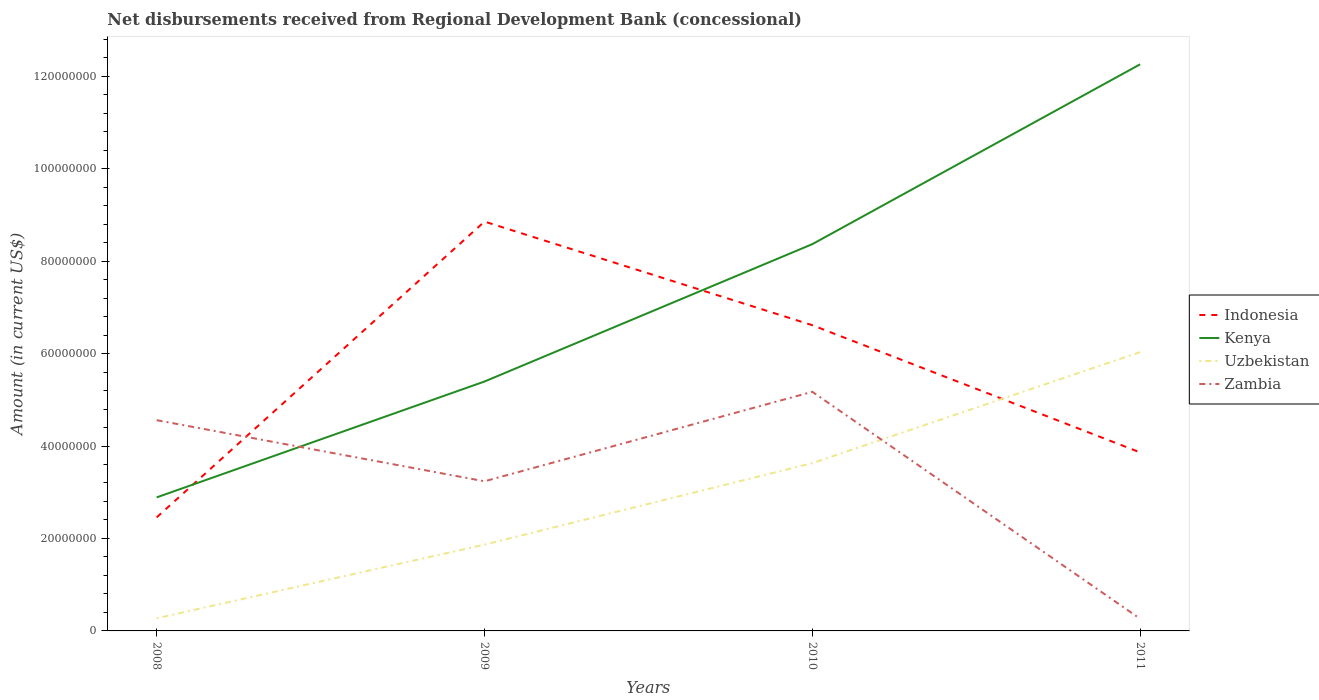Is the number of lines equal to the number of legend labels?
Ensure brevity in your answer.  Yes. Across all years, what is the maximum amount of disbursements received from Regional Development Bank in Kenya?
Make the answer very short. 2.89e+07. What is the total amount of disbursements received from Regional Development Bank in Indonesia in the graph?
Provide a short and direct response. -4.16e+07. What is the difference between the highest and the second highest amount of disbursements received from Regional Development Bank in Kenya?
Offer a terse response. 9.37e+07. How many years are there in the graph?
Your response must be concise. 4. What is the difference between two consecutive major ticks on the Y-axis?
Ensure brevity in your answer.  2.00e+07. Does the graph contain grids?
Your response must be concise. No. Where does the legend appear in the graph?
Make the answer very short. Center right. How many legend labels are there?
Make the answer very short. 4. What is the title of the graph?
Offer a very short reply. Net disbursements received from Regional Development Bank (concessional). Does "East Asia (all income levels)" appear as one of the legend labels in the graph?
Your answer should be compact. No. What is the label or title of the X-axis?
Provide a short and direct response. Years. What is the label or title of the Y-axis?
Offer a very short reply. Amount (in current US$). What is the Amount (in current US$) in Indonesia in 2008?
Make the answer very short. 2.46e+07. What is the Amount (in current US$) of Kenya in 2008?
Ensure brevity in your answer.  2.89e+07. What is the Amount (in current US$) of Uzbekistan in 2008?
Provide a short and direct response. 2.73e+06. What is the Amount (in current US$) of Zambia in 2008?
Make the answer very short. 4.56e+07. What is the Amount (in current US$) of Indonesia in 2009?
Offer a very short reply. 8.86e+07. What is the Amount (in current US$) in Kenya in 2009?
Make the answer very short. 5.40e+07. What is the Amount (in current US$) in Uzbekistan in 2009?
Offer a terse response. 1.87e+07. What is the Amount (in current US$) of Zambia in 2009?
Give a very brief answer. 3.24e+07. What is the Amount (in current US$) in Indonesia in 2010?
Offer a very short reply. 6.61e+07. What is the Amount (in current US$) of Kenya in 2010?
Provide a succinct answer. 8.37e+07. What is the Amount (in current US$) in Uzbekistan in 2010?
Keep it short and to the point. 3.63e+07. What is the Amount (in current US$) of Zambia in 2010?
Your response must be concise. 5.17e+07. What is the Amount (in current US$) of Indonesia in 2011?
Make the answer very short. 3.86e+07. What is the Amount (in current US$) in Kenya in 2011?
Ensure brevity in your answer.  1.23e+08. What is the Amount (in current US$) in Uzbekistan in 2011?
Your answer should be compact. 6.03e+07. What is the Amount (in current US$) of Zambia in 2011?
Provide a short and direct response. 2.63e+06. Across all years, what is the maximum Amount (in current US$) of Indonesia?
Your answer should be very brief. 8.86e+07. Across all years, what is the maximum Amount (in current US$) of Kenya?
Your answer should be very brief. 1.23e+08. Across all years, what is the maximum Amount (in current US$) of Uzbekistan?
Your answer should be compact. 6.03e+07. Across all years, what is the maximum Amount (in current US$) in Zambia?
Make the answer very short. 5.17e+07. Across all years, what is the minimum Amount (in current US$) in Indonesia?
Provide a short and direct response. 2.46e+07. Across all years, what is the minimum Amount (in current US$) of Kenya?
Provide a succinct answer. 2.89e+07. Across all years, what is the minimum Amount (in current US$) in Uzbekistan?
Your answer should be compact. 2.73e+06. Across all years, what is the minimum Amount (in current US$) of Zambia?
Provide a succinct answer. 2.63e+06. What is the total Amount (in current US$) of Indonesia in the graph?
Keep it short and to the point. 2.18e+08. What is the total Amount (in current US$) in Kenya in the graph?
Your answer should be very brief. 2.89e+08. What is the total Amount (in current US$) of Uzbekistan in the graph?
Make the answer very short. 1.18e+08. What is the total Amount (in current US$) in Zambia in the graph?
Offer a terse response. 1.32e+08. What is the difference between the Amount (in current US$) of Indonesia in 2008 and that in 2009?
Provide a succinct answer. -6.40e+07. What is the difference between the Amount (in current US$) in Kenya in 2008 and that in 2009?
Ensure brevity in your answer.  -2.51e+07. What is the difference between the Amount (in current US$) of Uzbekistan in 2008 and that in 2009?
Provide a short and direct response. -1.59e+07. What is the difference between the Amount (in current US$) of Zambia in 2008 and that in 2009?
Keep it short and to the point. 1.32e+07. What is the difference between the Amount (in current US$) in Indonesia in 2008 and that in 2010?
Your answer should be very brief. -4.16e+07. What is the difference between the Amount (in current US$) of Kenya in 2008 and that in 2010?
Your answer should be very brief. -5.48e+07. What is the difference between the Amount (in current US$) of Uzbekistan in 2008 and that in 2010?
Your response must be concise. -3.36e+07. What is the difference between the Amount (in current US$) of Zambia in 2008 and that in 2010?
Offer a very short reply. -6.14e+06. What is the difference between the Amount (in current US$) of Indonesia in 2008 and that in 2011?
Make the answer very short. -1.40e+07. What is the difference between the Amount (in current US$) of Kenya in 2008 and that in 2011?
Provide a succinct answer. -9.37e+07. What is the difference between the Amount (in current US$) in Uzbekistan in 2008 and that in 2011?
Your response must be concise. -5.76e+07. What is the difference between the Amount (in current US$) of Zambia in 2008 and that in 2011?
Provide a short and direct response. 4.30e+07. What is the difference between the Amount (in current US$) in Indonesia in 2009 and that in 2010?
Provide a short and direct response. 2.24e+07. What is the difference between the Amount (in current US$) of Kenya in 2009 and that in 2010?
Your response must be concise. -2.97e+07. What is the difference between the Amount (in current US$) in Uzbekistan in 2009 and that in 2010?
Provide a short and direct response. -1.76e+07. What is the difference between the Amount (in current US$) in Zambia in 2009 and that in 2010?
Give a very brief answer. -1.94e+07. What is the difference between the Amount (in current US$) of Indonesia in 2009 and that in 2011?
Your answer should be compact. 4.99e+07. What is the difference between the Amount (in current US$) of Kenya in 2009 and that in 2011?
Give a very brief answer. -6.86e+07. What is the difference between the Amount (in current US$) in Uzbekistan in 2009 and that in 2011?
Your answer should be compact. -4.16e+07. What is the difference between the Amount (in current US$) of Zambia in 2009 and that in 2011?
Offer a very short reply. 2.97e+07. What is the difference between the Amount (in current US$) of Indonesia in 2010 and that in 2011?
Offer a very short reply. 2.75e+07. What is the difference between the Amount (in current US$) of Kenya in 2010 and that in 2011?
Provide a succinct answer. -3.89e+07. What is the difference between the Amount (in current US$) of Uzbekistan in 2010 and that in 2011?
Keep it short and to the point. -2.40e+07. What is the difference between the Amount (in current US$) in Zambia in 2010 and that in 2011?
Offer a very short reply. 4.91e+07. What is the difference between the Amount (in current US$) in Indonesia in 2008 and the Amount (in current US$) in Kenya in 2009?
Make the answer very short. -2.94e+07. What is the difference between the Amount (in current US$) in Indonesia in 2008 and the Amount (in current US$) in Uzbekistan in 2009?
Provide a short and direct response. 5.90e+06. What is the difference between the Amount (in current US$) of Indonesia in 2008 and the Amount (in current US$) of Zambia in 2009?
Provide a short and direct response. -7.80e+06. What is the difference between the Amount (in current US$) in Kenya in 2008 and the Amount (in current US$) in Uzbekistan in 2009?
Offer a very short reply. 1.02e+07. What is the difference between the Amount (in current US$) of Kenya in 2008 and the Amount (in current US$) of Zambia in 2009?
Provide a short and direct response. -3.48e+06. What is the difference between the Amount (in current US$) in Uzbekistan in 2008 and the Amount (in current US$) in Zambia in 2009?
Offer a terse response. -2.96e+07. What is the difference between the Amount (in current US$) in Indonesia in 2008 and the Amount (in current US$) in Kenya in 2010?
Ensure brevity in your answer.  -5.91e+07. What is the difference between the Amount (in current US$) of Indonesia in 2008 and the Amount (in current US$) of Uzbekistan in 2010?
Make the answer very short. -1.17e+07. What is the difference between the Amount (in current US$) of Indonesia in 2008 and the Amount (in current US$) of Zambia in 2010?
Your answer should be compact. -2.72e+07. What is the difference between the Amount (in current US$) in Kenya in 2008 and the Amount (in current US$) in Uzbekistan in 2010?
Offer a very short reply. -7.41e+06. What is the difference between the Amount (in current US$) in Kenya in 2008 and the Amount (in current US$) in Zambia in 2010?
Your answer should be compact. -2.28e+07. What is the difference between the Amount (in current US$) in Uzbekistan in 2008 and the Amount (in current US$) in Zambia in 2010?
Your answer should be very brief. -4.90e+07. What is the difference between the Amount (in current US$) of Indonesia in 2008 and the Amount (in current US$) of Kenya in 2011?
Make the answer very short. -9.80e+07. What is the difference between the Amount (in current US$) of Indonesia in 2008 and the Amount (in current US$) of Uzbekistan in 2011?
Your response must be concise. -3.58e+07. What is the difference between the Amount (in current US$) in Indonesia in 2008 and the Amount (in current US$) in Zambia in 2011?
Provide a succinct answer. 2.19e+07. What is the difference between the Amount (in current US$) in Kenya in 2008 and the Amount (in current US$) in Uzbekistan in 2011?
Offer a very short reply. -3.14e+07. What is the difference between the Amount (in current US$) in Kenya in 2008 and the Amount (in current US$) in Zambia in 2011?
Give a very brief answer. 2.63e+07. What is the difference between the Amount (in current US$) of Uzbekistan in 2008 and the Amount (in current US$) of Zambia in 2011?
Give a very brief answer. 1.05e+05. What is the difference between the Amount (in current US$) of Indonesia in 2009 and the Amount (in current US$) of Kenya in 2010?
Give a very brief answer. 4.88e+06. What is the difference between the Amount (in current US$) of Indonesia in 2009 and the Amount (in current US$) of Uzbekistan in 2010?
Give a very brief answer. 5.23e+07. What is the difference between the Amount (in current US$) in Indonesia in 2009 and the Amount (in current US$) in Zambia in 2010?
Offer a terse response. 3.68e+07. What is the difference between the Amount (in current US$) of Kenya in 2009 and the Amount (in current US$) of Uzbekistan in 2010?
Make the answer very short. 1.77e+07. What is the difference between the Amount (in current US$) in Kenya in 2009 and the Amount (in current US$) in Zambia in 2010?
Offer a very short reply. 2.23e+06. What is the difference between the Amount (in current US$) in Uzbekistan in 2009 and the Amount (in current US$) in Zambia in 2010?
Keep it short and to the point. -3.31e+07. What is the difference between the Amount (in current US$) in Indonesia in 2009 and the Amount (in current US$) in Kenya in 2011?
Offer a terse response. -3.40e+07. What is the difference between the Amount (in current US$) in Indonesia in 2009 and the Amount (in current US$) in Uzbekistan in 2011?
Your answer should be compact. 2.82e+07. What is the difference between the Amount (in current US$) of Indonesia in 2009 and the Amount (in current US$) of Zambia in 2011?
Provide a succinct answer. 8.59e+07. What is the difference between the Amount (in current US$) in Kenya in 2009 and the Amount (in current US$) in Uzbekistan in 2011?
Give a very brief answer. -6.37e+06. What is the difference between the Amount (in current US$) of Kenya in 2009 and the Amount (in current US$) of Zambia in 2011?
Give a very brief answer. 5.13e+07. What is the difference between the Amount (in current US$) of Uzbekistan in 2009 and the Amount (in current US$) of Zambia in 2011?
Keep it short and to the point. 1.60e+07. What is the difference between the Amount (in current US$) in Indonesia in 2010 and the Amount (in current US$) in Kenya in 2011?
Ensure brevity in your answer.  -5.64e+07. What is the difference between the Amount (in current US$) in Indonesia in 2010 and the Amount (in current US$) in Uzbekistan in 2011?
Provide a succinct answer. 5.82e+06. What is the difference between the Amount (in current US$) in Indonesia in 2010 and the Amount (in current US$) in Zambia in 2011?
Your response must be concise. 6.35e+07. What is the difference between the Amount (in current US$) of Kenya in 2010 and the Amount (in current US$) of Uzbekistan in 2011?
Ensure brevity in your answer.  2.34e+07. What is the difference between the Amount (in current US$) in Kenya in 2010 and the Amount (in current US$) in Zambia in 2011?
Give a very brief answer. 8.10e+07. What is the difference between the Amount (in current US$) in Uzbekistan in 2010 and the Amount (in current US$) in Zambia in 2011?
Ensure brevity in your answer.  3.37e+07. What is the average Amount (in current US$) of Indonesia per year?
Provide a succinct answer. 5.45e+07. What is the average Amount (in current US$) of Kenya per year?
Your answer should be very brief. 7.23e+07. What is the average Amount (in current US$) in Uzbekistan per year?
Provide a short and direct response. 2.95e+07. What is the average Amount (in current US$) in Zambia per year?
Provide a succinct answer. 3.31e+07. In the year 2008, what is the difference between the Amount (in current US$) in Indonesia and Amount (in current US$) in Kenya?
Provide a succinct answer. -4.32e+06. In the year 2008, what is the difference between the Amount (in current US$) of Indonesia and Amount (in current US$) of Uzbekistan?
Provide a succinct answer. 2.18e+07. In the year 2008, what is the difference between the Amount (in current US$) in Indonesia and Amount (in current US$) in Zambia?
Provide a short and direct response. -2.10e+07. In the year 2008, what is the difference between the Amount (in current US$) in Kenya and Amount (in current US$) in Uzbekistan?
Make the answer very short. 2.62e+07. In the year 2008, what is the difference between the Amount (in current US$) of Kenya and Amount (in current US$) of Zambia?
Give a very brief answer. -1.67e+07. In the year 2008, what is the difference between the Amount (in current US$) in Uzbekistan and Amount (in current US$) in Zambia?
Keep it short and to the point. -4.29e+07. In the year 2009, what is the difference between the Amount (in current US$) of Indonesia and Amount (in current US$) of Kenya?
Offer a very short reply. 3.46e+07. In the year 2009, what is the difference between the Amount (in current US$) of Indonesia and Amount (in current US$) of Uzbekistan?
Give a very brief answer. 6.99e+07. In the year 2009, what is the difference between the Amount (in current US$) in Indonesia and Amount (in current US$) in Zambia?
Your answer should be very brief. 5.62e+07. In the year 2009, what is the difference between the Amount (in current US$) of Kenya and Amount (in current US$) of Uzbekistan?
Provide a succinct answer. 3.53e+07. In the year 2009, what is the difference between the Amount (in current US$) of Kenya and Amount (in current US$) of Zambia?
Offer a terse response. 2.16e+07. In the year 2009, what is the difference between the Amount (in current US$) of Uzbekistan and Amount (in current US$) of Zambia?
Your answer should be very brief. -1.37e+07. In the year 2010, what is the difference between the Amount (in current US$) of Indonesia and Amount (in current US$) of Kenya?
Give a very brief answer. -1.75e+07. In the year 2010, what is the difference between the Amount (in current US$) of Indonesia and Amount (in current US$) of Uzbekistan?
Ensure brevity in your answer.  2.98e+07. In the year 2010, what is the difference between the Amount (in current US$) in Indonesia and Amount (in current US$) in Zambia?
Provide a short and direct response. 1.44e+07. In the year 2010, what is the difference between the Amount (in current US$) of Kenya and Amount (in current US$) of Uzbekistan?
Give a very brief answer. 4.74e+07. In the year 2010, what is the difference between the Amount (in current US$) of Kenya and Amount (in current US$) of Zambia?
Make the answer very short. 3.19e+07. In the year 2010, what is the difference between the Amount (in current US$) in Uzbekistan and Amount (in current US$) in Zambia?
Ensure brevity in your answer.  -1.54e+07. In the year 2011, what is the difference between the Amount (in current US$) in Indonesia and Amount (in current US$) in Kenya?
Make the answer very short. -8.40e+07. In the year 2011, what is the difference between the Amount (in current US$) in Indonesia and Amount (in current US$) in Uzbekistan?
Make the answer very short. -2.17e+07. In the year 2011, what is the difference between the Amount (in current US$) of Indonesia and Amount (in current US$) of Zambia?
Provide a short and direct response. 3.60e+07. In the year 2011, what is the difference between the Amount (in current US$) in Kenya and Amount (in current US$) in Uzbekistan?
Provide a short and direct response. 6.23e+07. In the year 2011, what is the difference between the Amount (in current US$) of Kenya and Amount (in current US$) of Zambia?
Offer a very short reply. 1.20e+08. In the year 2011, what is the difference between the Amount (in current US$) of Uzbekistan and Amount (in current US$) of Zambia?
Your answer should be very brief. 5.77e+07. What is the ratio of the Amount (in current US$) in Indonesia in 2008 to that in 2009?
Give a very brief answer. 0.28. What is the ratio of the Amount (in current US$) of Kenya in 2008 to that in 2009?
Provide a succinct answer. 0.54. What is the ratio of the Amount (in current US$) of Uzbekistan in 2008 to that in 2009?
Your answer should be very brief. 0.15. What is the ratio of the Amount (in current US$) in Zambia in 2008 to that in 2009?
Your answer should be very brief. 1.41. What is the ratio of the Amount (in current US$) of Indonesia in 2008 to that in 2010?
Provide a short and direct response. 0.37. What is the ratio of the Amount (in current US$) of Kenya in 2008 to that in 2010?
Offer a very short reply. 0.35. What is the ratio of the Amount (in current US$) of Uzbekistan in 2008 to that in 2010?
Provide a short and direct response. 0.08. What is the ratio of the Amount (in current US$) in Zambia in 2008 to that in 2010?
Keep it short and to the point. 0.88. What is the ratio of the Amount (in current US$) of Indonesia in 2008 to that in 2011?
Give a very brief answer. 0.64. What is the ratio of the Amount (in current US$) of Kenya in 2008 to that in 2011?
Make the answer very short. 0.24. What is the ratio of the Amount (in current US$) of Uzbekistan in 2008 to that in 2011?
Give a very brief answer. 0.05. What is the ratio of the Amount (in current US$) in Zambia in 2008 to that in 2011?
Provide a short and direct response. 17.36. What is the ratio of the Amount (in current US$) in Indonesia in 2009 to that in 2010?
Give a very brief answer. 1.34. What is the ratio of the Amount (in current US$) in Kenya in 2009 to that in 2010?
Your answer should be compact. 0.64. What is the ratio of the Amount (in current US$) of Uzbekistan in 2009 to that in 2010?
Your answer should be very brief. 0.51. What is the ratio of the Amount (in current US$) in Zambia in 2009 to that in 2010?
Keep it short and to the point. 0.63. What is the ratio of the Amount (in current US$) in Indonesia in 2009 to that in 2011?
Provide a succinct answer. 2.29. What is the ratio of the Amount (in current US$) of Kenya in 2009 to that in 2011?
Offer a terse response. 0.44. What is the ratio of the Amount (in current US$) of Uzbekistan in 2009 to that in 2011?
Make the answer very short. 0.31. What is the ratio of the Amount (in current US$) in Zambia in 2009 to that in 2011?
Provide a short and direct response. 12.33. What is the ratio of the Amount (in current US$) of Indonesia in 2010 to that in 2011?
Make the answer very short. 1.71. What is the ratio of the Amount (in current US$) of Kenya in 2010 to that in 2011?
Your response must be concise. 0.68. What is the ratio of the Amount (in current US$) of Uzbekistan in 2010 to that in 2011?
Keep it short and to the point. 0.6. What is the ratio of the Amount (in current US$) in Zambia in 2010 to that in 2011?
Your response must be concise. 19.7. What is the difference between the highest and the second highest Amount (in current US$) in Indonesia?
Ensure brevity in your answer.  2.24e+07. What is the difference between the highest and the second highest Amount (in current US$) of Kenya?
Your response must be concise. 3.89e+07. What is the difference between the highest and the second highest Amount (in current US$) in Uzbekistan?
Your answer should be very brief. 2.40e+07. What is the difference between the highest and the second highest Amount (in current US$) in Zambia?
Your answer should be compact. 6.14e+06. What is the difference between the highest and the lowest Amount (in current US$) in Indonesia?
Make the answer very short. 6.40e+07. What is the difference between the highest and the lowest Amount (in current US$) in Kenya?
Keep it short and to the point. 9.37e+07. What is the difference between the highest and the lowest Amount (in current US$) of Uzbekistan?
Make the answer very short. 5.76e+07. What is the difference between the highest and the lowest Amount (in current US$) of Zambia?
Give a very brief answer. 4.91e+07. 